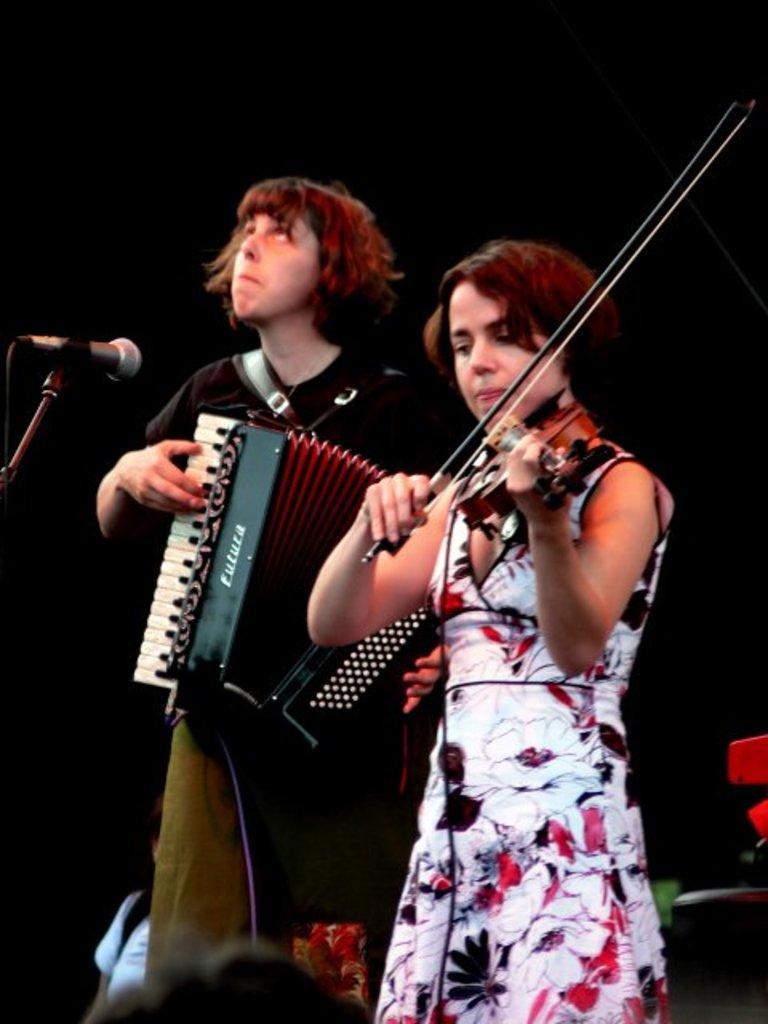In one or two sentences, can you explain what this image depicts? As we can see in the image there are two people. The women is playing guitar and the man who is standing here is playing musical instrument and there is a mic. 